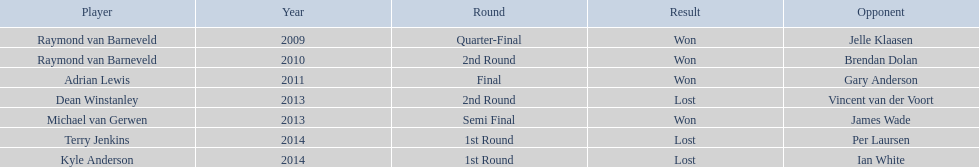Who are the athletes competing in the pdc world darts championship? Raymond van Barneveld, Raymond van Barneveld, Adrian Lewis, Dean Winstanley, Michael van Gerwen, Terry Jenkins, Kyle Anderson. When did kyle anderson suffer a loss? 2014. Which additional players were eliminated in 2014? Terry Jenkins. 